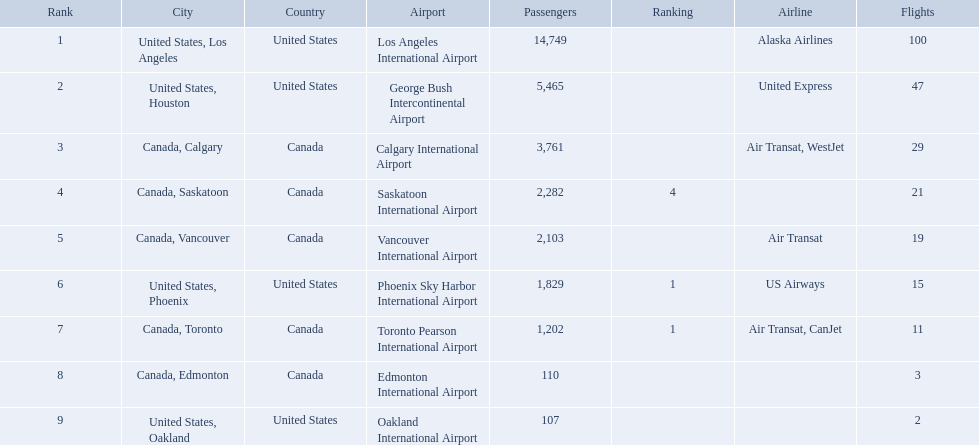What are all the cities? United States, Los Angeles, United States, Houston, Canada, Calgary, Canada, Saskatoon, Canada, Vancouver, United States, Phoenix, Canada, Toronto, Canada, Edmonton, United States, Oakland. How many passengers do they service? 14,749, 5,465, 3,761, 2,282, 2,103, 1,829, 1,202, 110, 107. Which city, when combined with los angeles, totals nearly 19,000? Canada, Calgary. What were all the passenger totals? 14,749, 5,465, 3,761, 2,282, 2,103, 1,829, 1,202, 110, 107. Which of these were to los angeles? 14,749. What other destination combined with this is closest to 19,000? Canada, Calgary. Where are the destinations of the airport? United States, Los Angeles, United States, Houston, Canada, Calgary, Canada, Saskatoon, Canada, Vancouver, United States, Phoenix, Canada, Toronto, Canada, Edmonton, United States, Oakland. What is the number of passengers to phoenix? 1,829. 